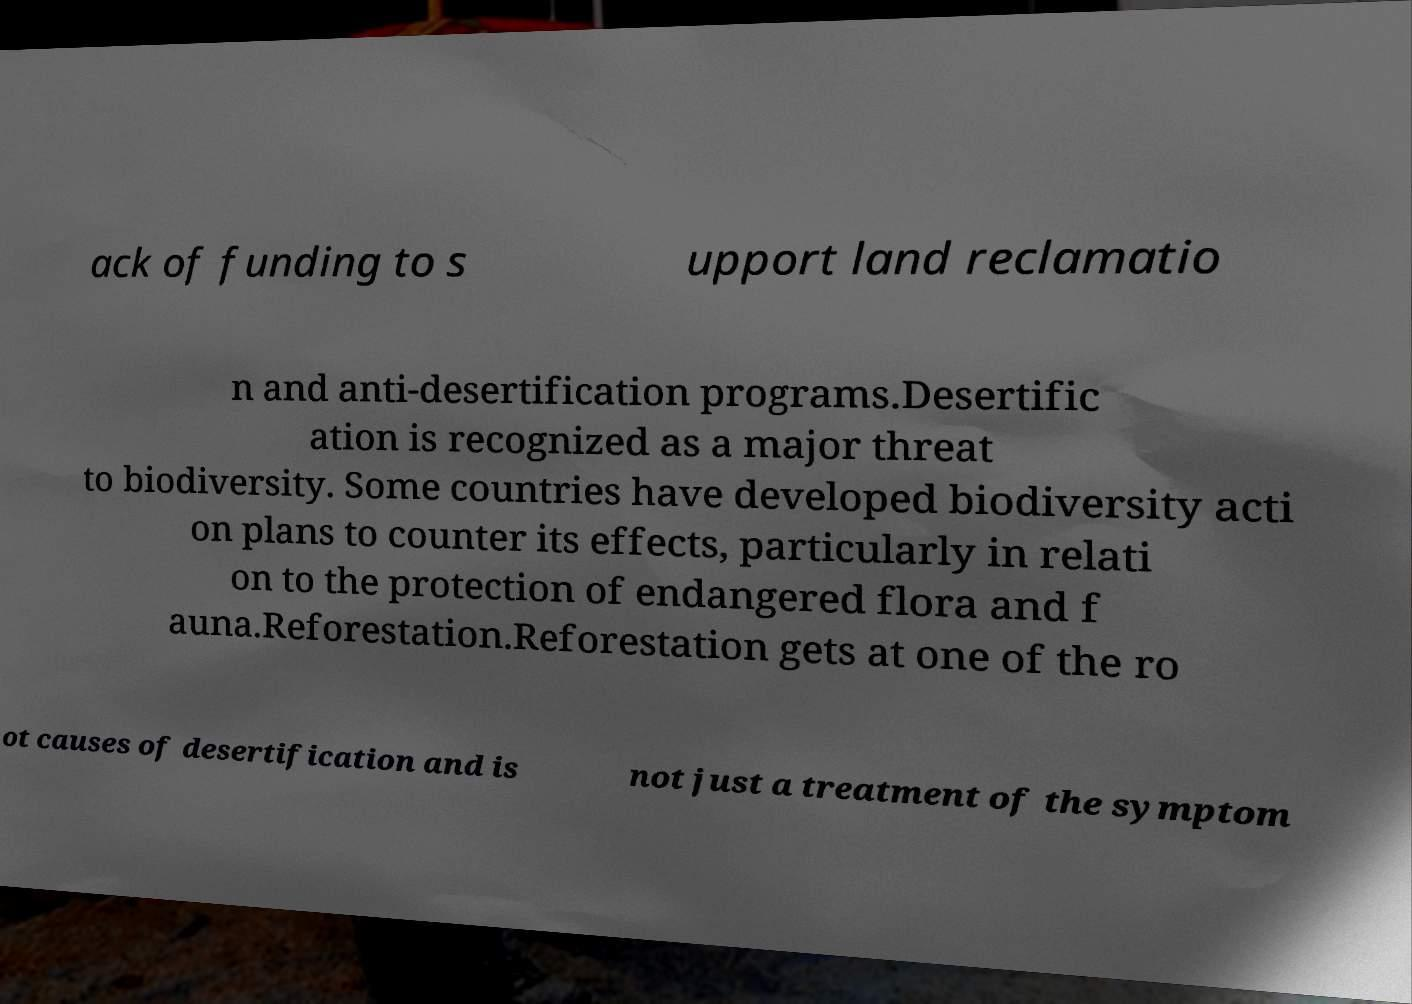Please identify and transcribe the text found in this image. ack of funding to s upport land reclamatio n and anti-desertification programs.Desertific ation is recognized as a major threat to biodiversity. Some countries have developed biodiversity acti on plans to counter its effects, particularly in relati on to the protection of endangered flora and f auna.Reforestation.Reforestation gets at one of the ro ot causes of desertification and is not just a treatment of the symptom 